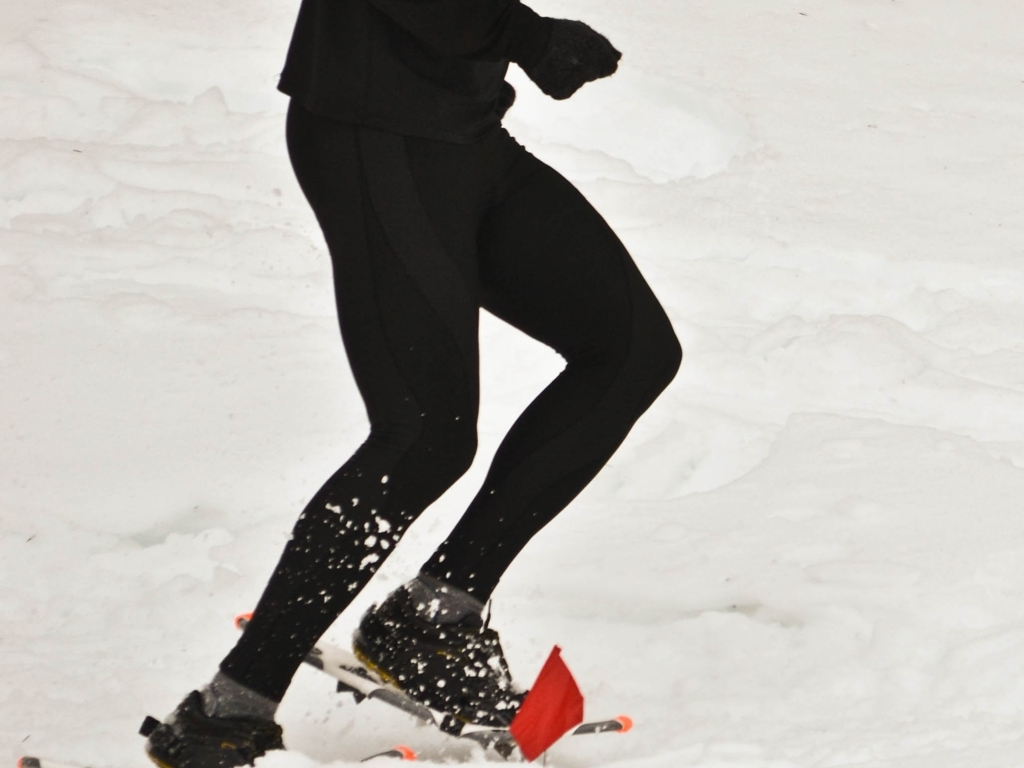What can you tell about the environment and weather in the image? The environment in the image looks cold and snowy, indicative of winter weather conditions. The ground is covered with snow, and the diffuse lighting suggests it might be an overcast day, typical of snowy regions. The lack of shadows points to an absence of direct sunlight. The attire of the person, consisting of long sleeves and leggings, is appropriate for cold-weather activity. 